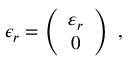Convert formula to latex. <formula><loc_0><loc_0><loc_500><loc_500>\epsilon _ { r } = \left ( \begin{array} { c } { { \varepsilon _ { r } } } \\ { 0 } \end{array} \right ) \ ,</formula> 